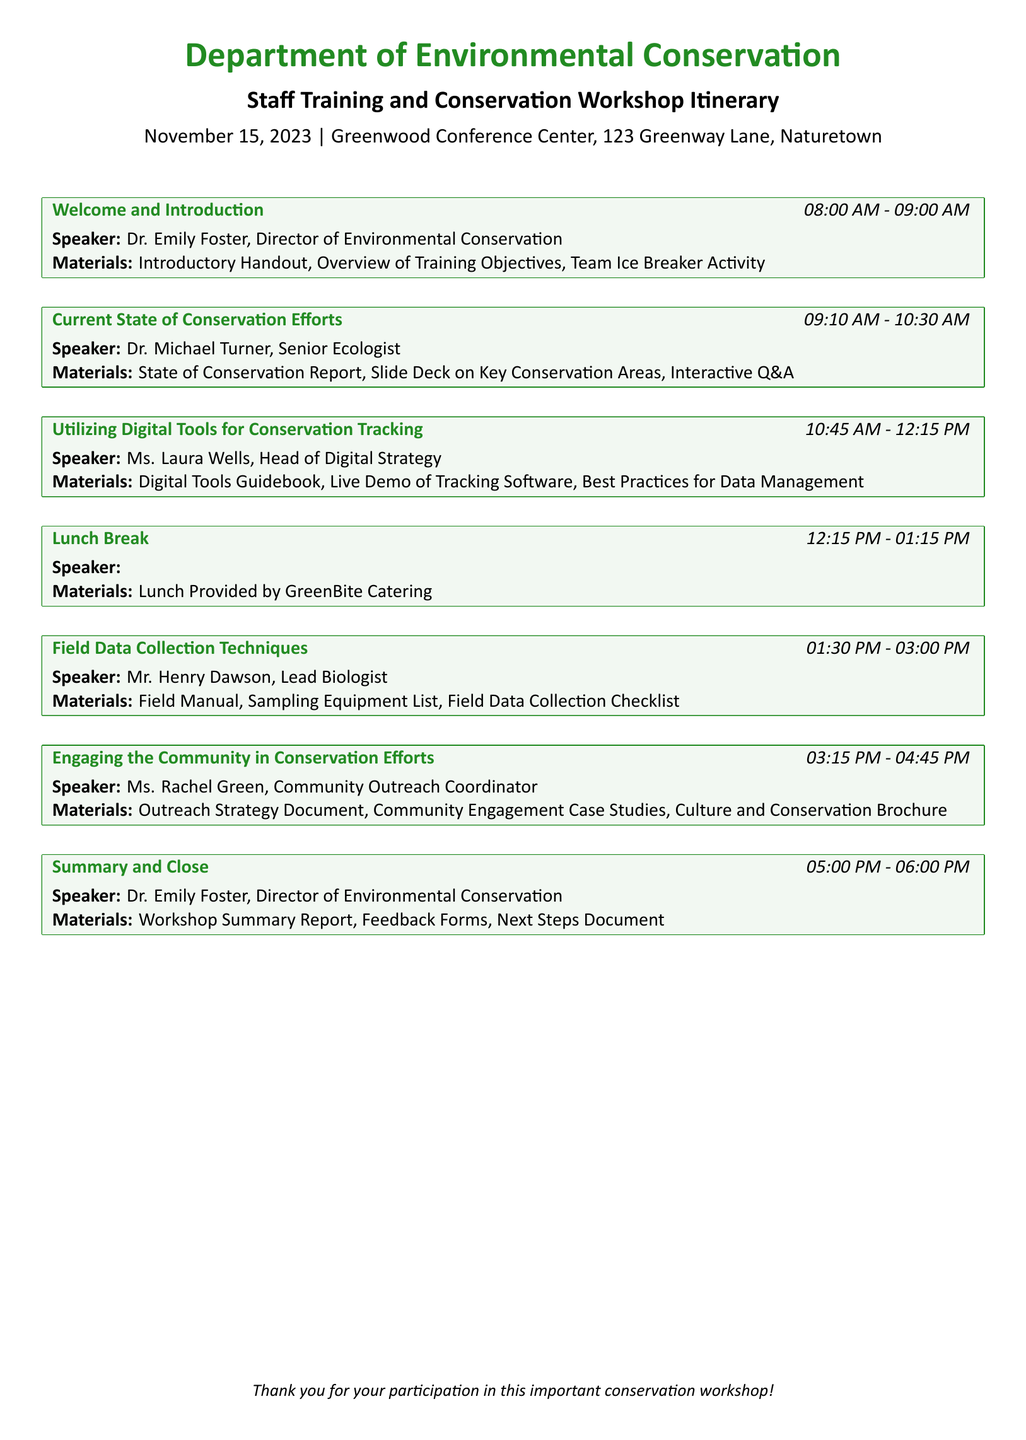What time does the training start? The training begins at 08:00 AM as indicated in the document.
Answer: 08:00 AM Who is the speaker for the session on “Field Data Collection Techniques”? The speaker for that session is Mr. Henry Dawson, as stated in the itinerary.
Answer: Mr. Henry Dawson What is the topic of the session following lunch? The session right after lunch is focused on "Field Data Collection Techniques".
Answer: Field Data Collection Techniques How long is the lunch break? The lunch break is scheduled for one hour, from 12:15 PM to 01:15 PM.
Answer: One hour What is included in the training materials for the “Utilizing Digital Tools for Conservation Tracking” session? The training materials for that session include a Digital Tools Guidebook and a Live Demo of Tracking Software.
Answer: Digital Tools Guidebook, Live Demo of Tracking Software Which session ends last in the day? The last session of the day is "Summary and Close", which concludes at 06:00 PM.
Answer: Summary and Close What type of document is this? The document is an itinerary detailing training sessions and workshops for staff.
Answer: Itinerary Who provides lunch for the participants? The lunch is provided by GreenBite Catering, as mentioned in the document.
Answer: GreenBite Catering 